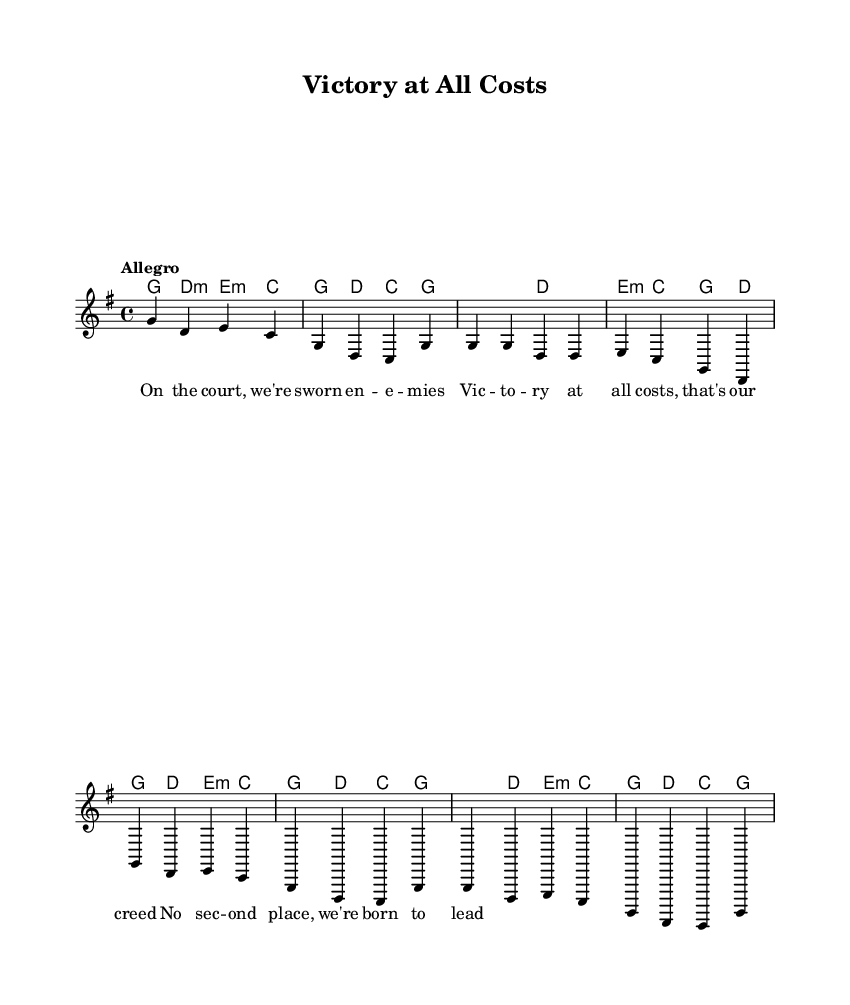What is the key signature of this music? The key signature is G major, which has one sharp (F#). This is indicated at the beginning of the sheet music in the global settings.
Answer: G major What is the time signature of this music? The time signature is 4/4, which means there are four beats per measure. This is specified in the global settings at the beginning of the sheet music.
Answer: 4/4 What tempo marking is indicated? The tempo marking is "Allegro," indicating a fast and lively pace. This is clearly stated in the global settings at the top of the sheet music.
Answer: Allegro How many measures are in the chorus section? The chorus section contains four measures, as seen in the melody. Each measure is represented by a group of notes separated by vertical lines.
Answer: Four What is the primary theme expressed in the lyrics? The primary theme is intense competition and the desire for victory, as evident in the repeated phrase "Victory at all costs." This captures the spirit of rivalry in sports.
Answer: Intense competition What is the chord played during the lyrics "No sec -- ond place, we're born to lead"? The chord during this phrase is E minor, as indicated in the harmonies section where it corresponds to the melody notes in that part.
Answer: E minor 